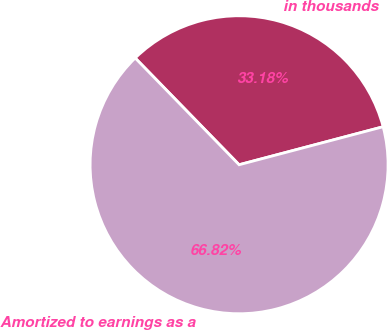Convert chart to OTSL. <chart><loc_0><loc_0><loc_500><loc_500><pie_chart><fcel>in thousands<fcel>Amortized to earnings as a<nl><fcel>33.18%<fcel>66.82%<nl></chart> 